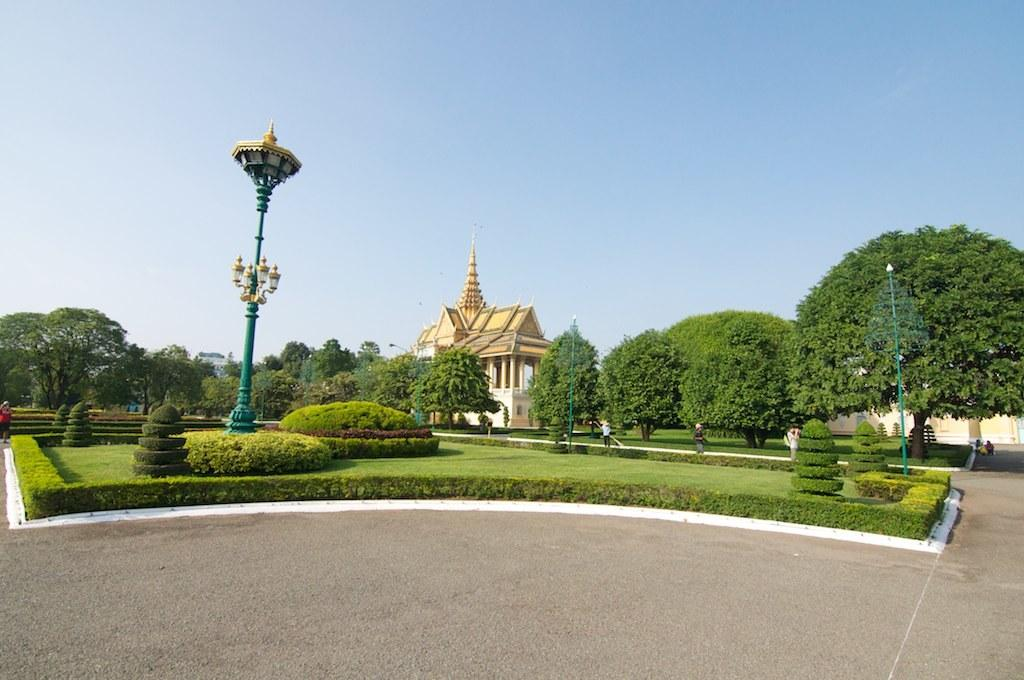What is the main feature of the image? There is a road in the image. What else can be seen along the road? There are plants visible in the image. What is visible in the background of the image? There are trees, a house, and the sky visible in the background of the image. Where is the throne located in the image? There is no throne present in the image. What type of division can be seen between the plants and the road in the image? The image does not show any divisions between the plants and the road; they are simply adjacent to each other. 